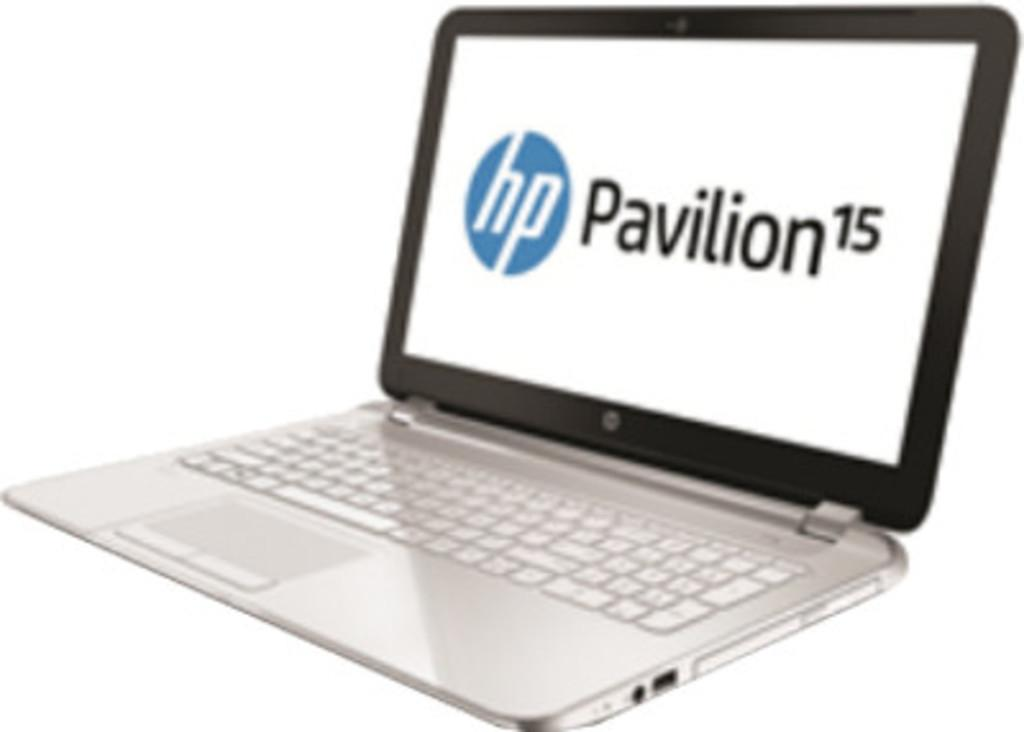<image>
Offer a succinct explanation of the picture presented. an HP Pavilion 15 lap top computer on display 